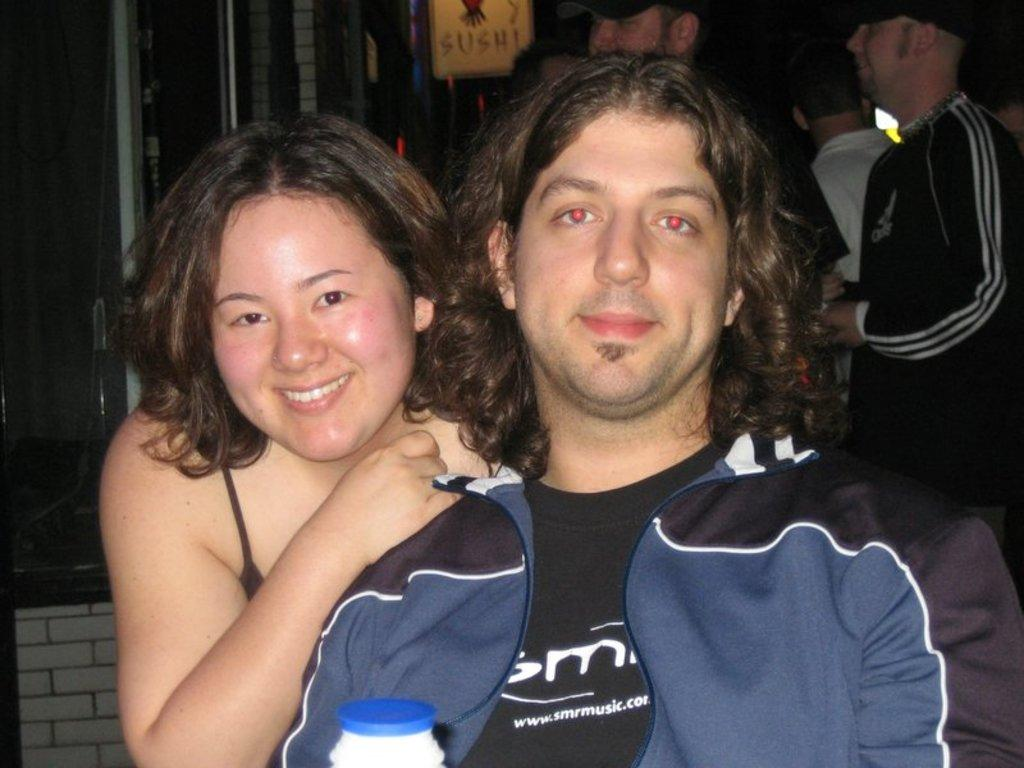What can be seen in the background of the image? There are people standing in the background of the image. What is on the board that is visible in the image? There is a board with text in the image. What is the man in the image doing? The man is sitting in the image. Who else is present in the image besides the man? There is a woman in the image. What type of vegetable is the woman holding in the image? There is no vegetable present in the image; the woman is not holding anything. What idea is being celebrated in the image? There is no indication of a celebration or idea being celebrated in the image. 